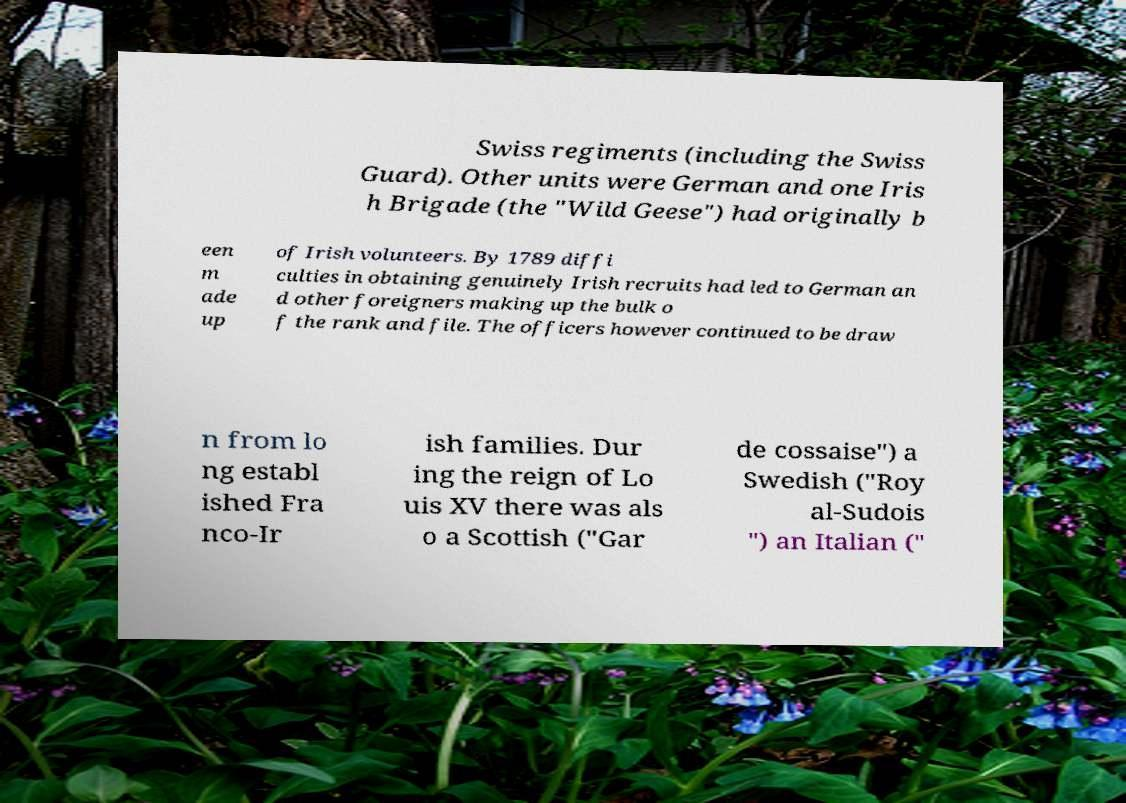There's text embedded in this image that I need extracted. Can you transcribe it verbatim? Swiss regiments (including the Swiss Guard). Other units were German and one Iris h Brigade (the "Wild Geese") had originally b een m ade up of Irish volunteers. By 1789 diffi culties in obtaining genuinely Irish recruits had led to German an d other foreigners making up the bulk o f the rank and file. The officers however continued to be draw n from lo ng establ ished Fra nco-Ir ish families. Dur ing the reign of Lo uis XV there was als o a Scottish ("Gar de cossaise") a Swedish ("Roy al-Sudois ") an Italian (" 